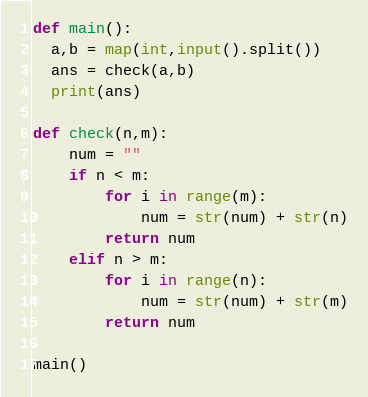<code> <loc_0><loc_0><loc_500><loc_500><_Python_>def main():
  a,b = map(int,input().split())
  ans = check(a,b)
  print(ans)
  
def check(n,m):
    num = ""
    if n < m:
        for i in range(m):
            num = str(num) + str(n)
        return num
    elif n > m:
        for i in range(n):
            num = str(num) + str(m)
        return num

main()</code> 